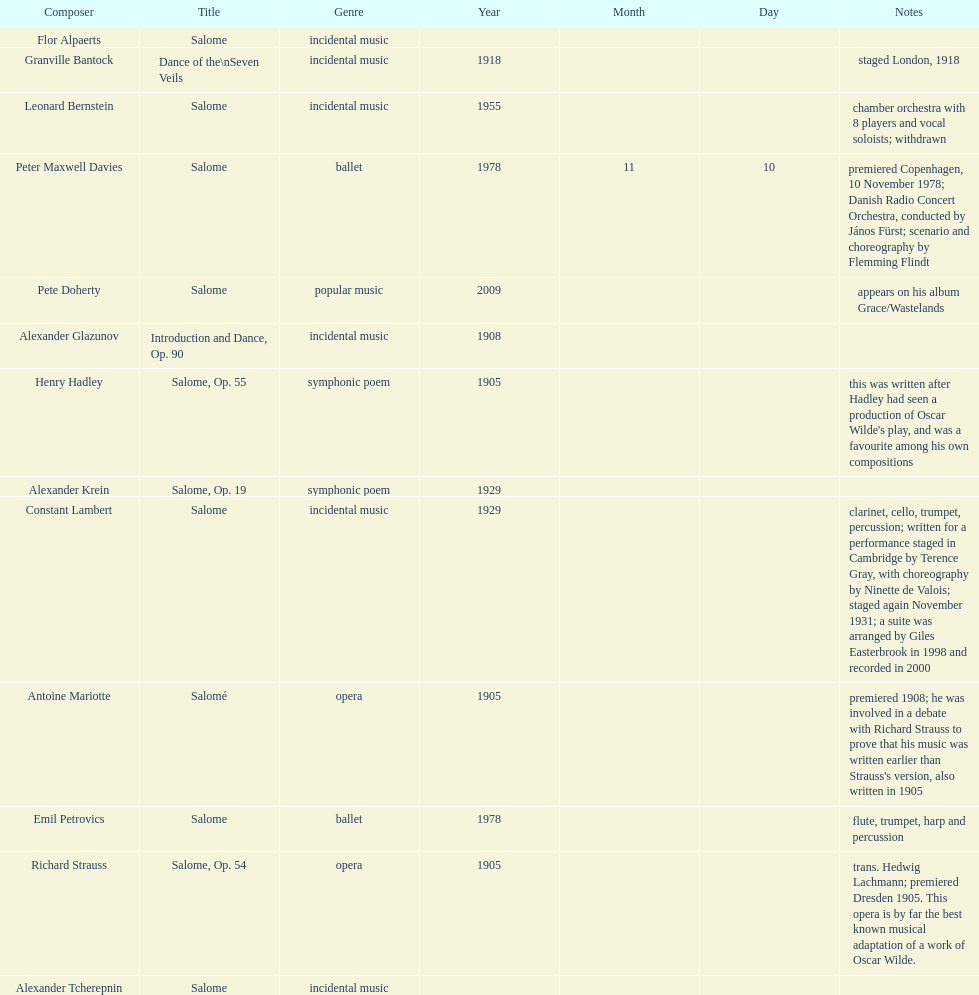Why type of genre was peter maxwell davies' work that was the same as emil petrovics' Ballet. 